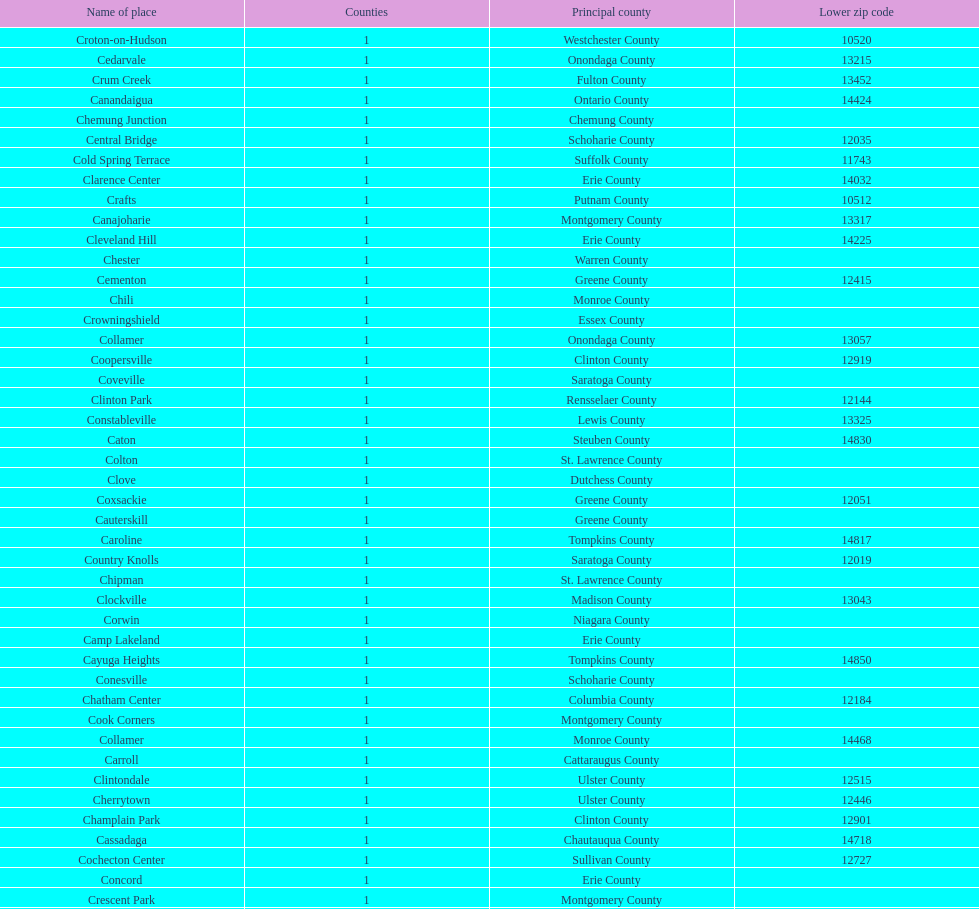How many total places are in greene county? 10. 